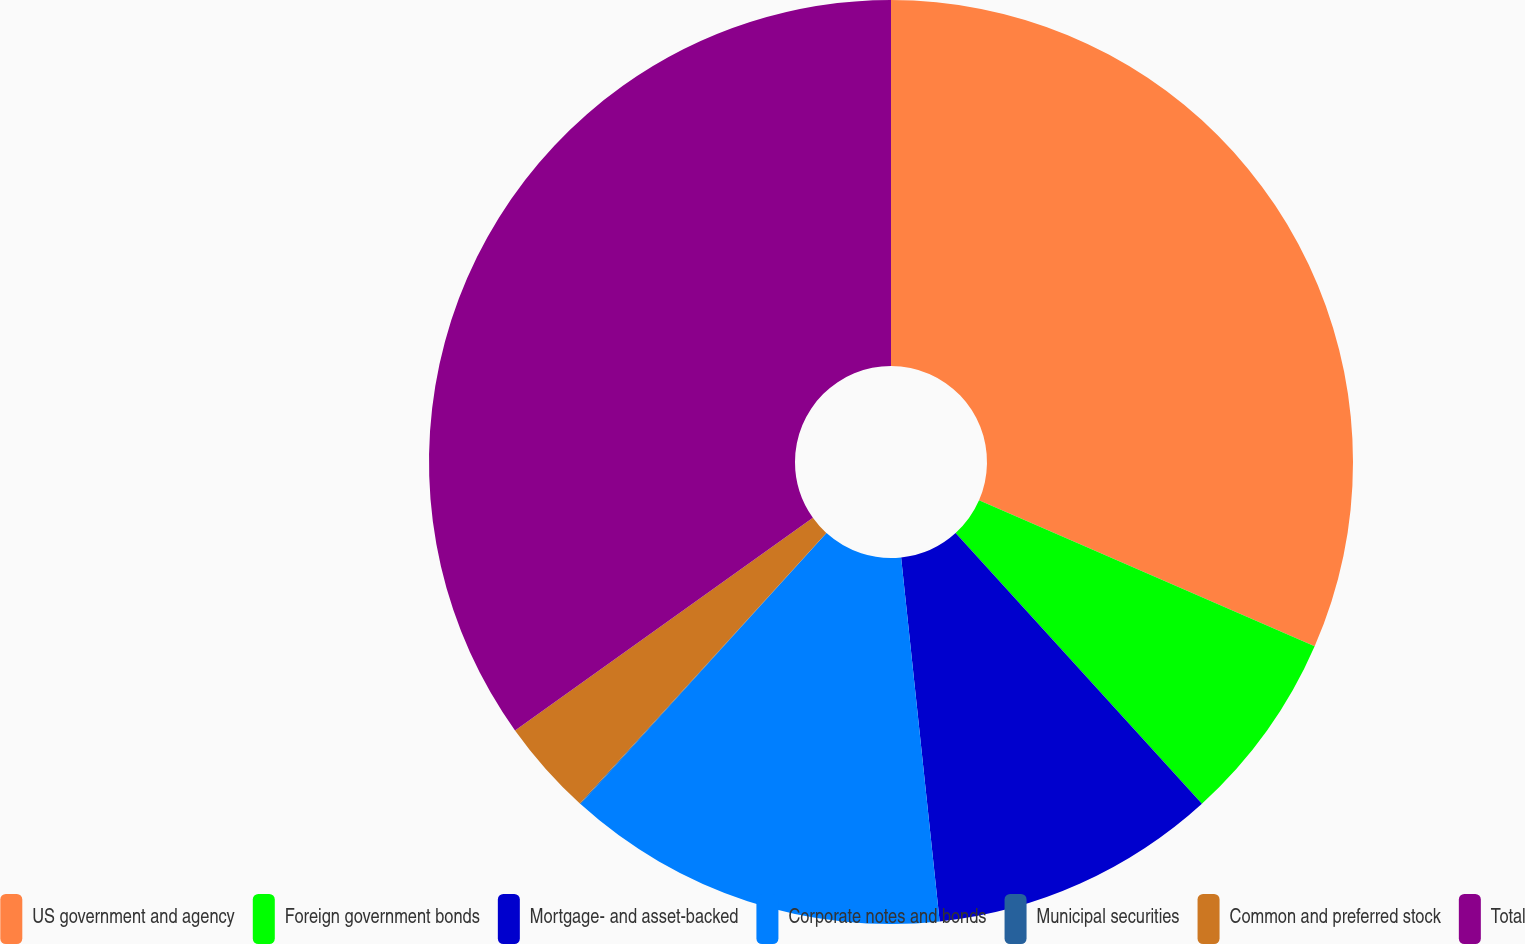Convert chart to OTSL. <chart><loc_0><loc_0><loc_500><loc_500><pie_chart><fcel>US government and agency<fcel>Foreign government bonds<fcel>Mortgage- and asset-backed<fcel>Corporate notes and bonds<fcel>Municipal securities<fcel>Common and preferred stock<fcel>Total<nl><fcel>31.53%<fcel>6.72%<fcel>10.07%<fcel>13.41%<fcel>0.03%<fcel>3.37%<fcel>34.87%<nl></chart> 